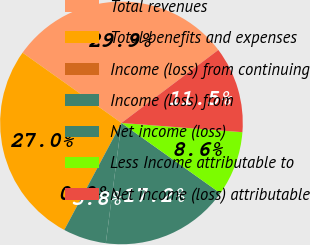Convert chart to OTSL. <chart><loc_0><loc_0><loc_500><loc_500><pie_chart><fcel>Total revenues<fcel>Total benefits and expenses<fcel>Income (loss) from continuing<fcel>Income (loss) from<fcel>Net income (loss)<fcel>Less Income attributable to<fcel>Net income (loss) attributable<nl><fcel>29.89%<fcel>27.02%<fcel>0.0%<fcel>5.75%<fcel>17.23%<fcel>8.62%<fcel>11.49%<nl></chart> 